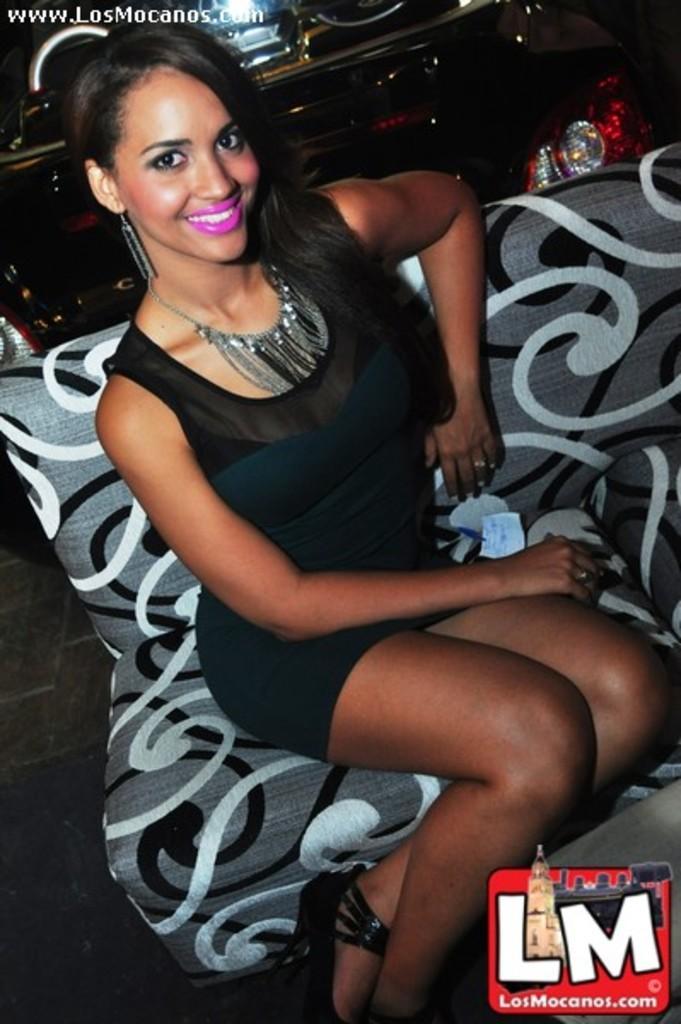Could you give a brief overview of what you see in this image? In this image I see a woman who is smiling and I see that she is wearing black and dark green dress and I see that she is wearing a necklace and I see that she is sitting on a couch which is of grey, white and black in color. In the background I see the red and silver color thing over here and I see the light over here and I see the watermark on the top and I see another watermark over here and it is a bit dark in the background. 